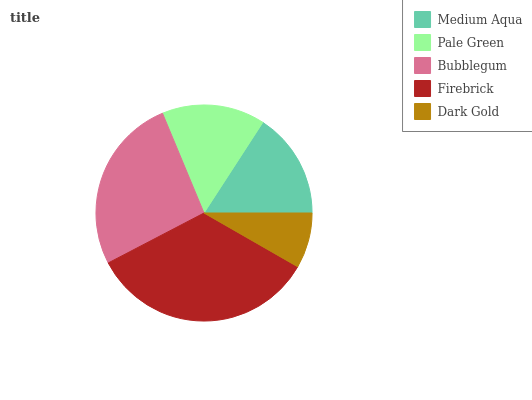Is Dark Gold the minimum?
Answer yes or no. Yes. Is Firebrick the maximum?
Answer yes or no. Yes. Is Pale Green the minimum?
Answer yes or no. No. Is Pale Green the maximum?
Answer yes or no. No. Is Medium Aqua greater than Pale Green?
Answer yes or no. Yes. Is Pale Green less than Medium Aqua?
Answer yes or no. Yes. Is Pale Green greater than Medium Aqua?
Answer yes or no. No. Is Medium Aqua less than Pale Green?
Answer yes or no. No. Is Medium Aqua the high median?
Answer yes or no. Yes. Is Medium Aqua the low median?
Answer yes or no. Yes. Is Dark Gold the high median?
Answer yes or no. No. Is Pale Green the low median?
Answer yes or no. No. 